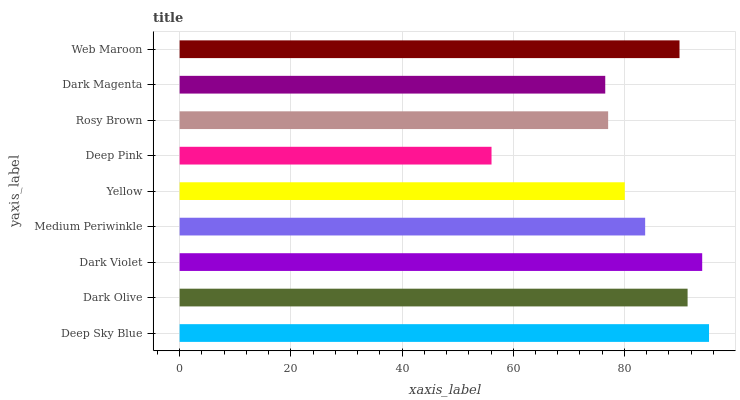Is Deep Pink the minimum?
Answer yes or no. Yes. Is Deep Sky Blue the maximum?
Answer yes or no. Yes. Is Dark Olive the minimum?
Answer yes or no. No. Is Dark Olive the maximum?
Answer yes or no. No. Is Deep Sky Blue greater than Dark Olive?
Answer yes or no. Yes. Is Dark Olive less than Deep Sky Blue?
Answer yes or no. Yes. Is Dark Olive greater than Deep Sky Blue?
Answer yes or no. No. Is Deep Sky Blue less than Dark Olive?
Answer yes or no. No. Is Medium Periwinkle the high median?
Answer yes or no. Yes. Is Medium Periwinkle the low median?
Answer yes or no. Yes. Is Dark Magenta the high median?
Answer yes or no. No. Is Web Maroon the low median?
Answer yes or no. No. 